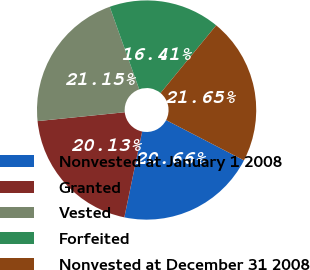Convert chart to OTSL. <chart><loc_0><loc_0><loc_500><loc_500><pie_chart><fcel>Nonvested at January 1 2008<fcel>Granted<fcel>Vested<fcel>Forfeited<fcel>Nonvested at December 31 2008<nl><fcel>20.66%<fcel>20.13%<fcel>21.15%<fcel>16.41%<fcel>21.65%<nl></chart> 